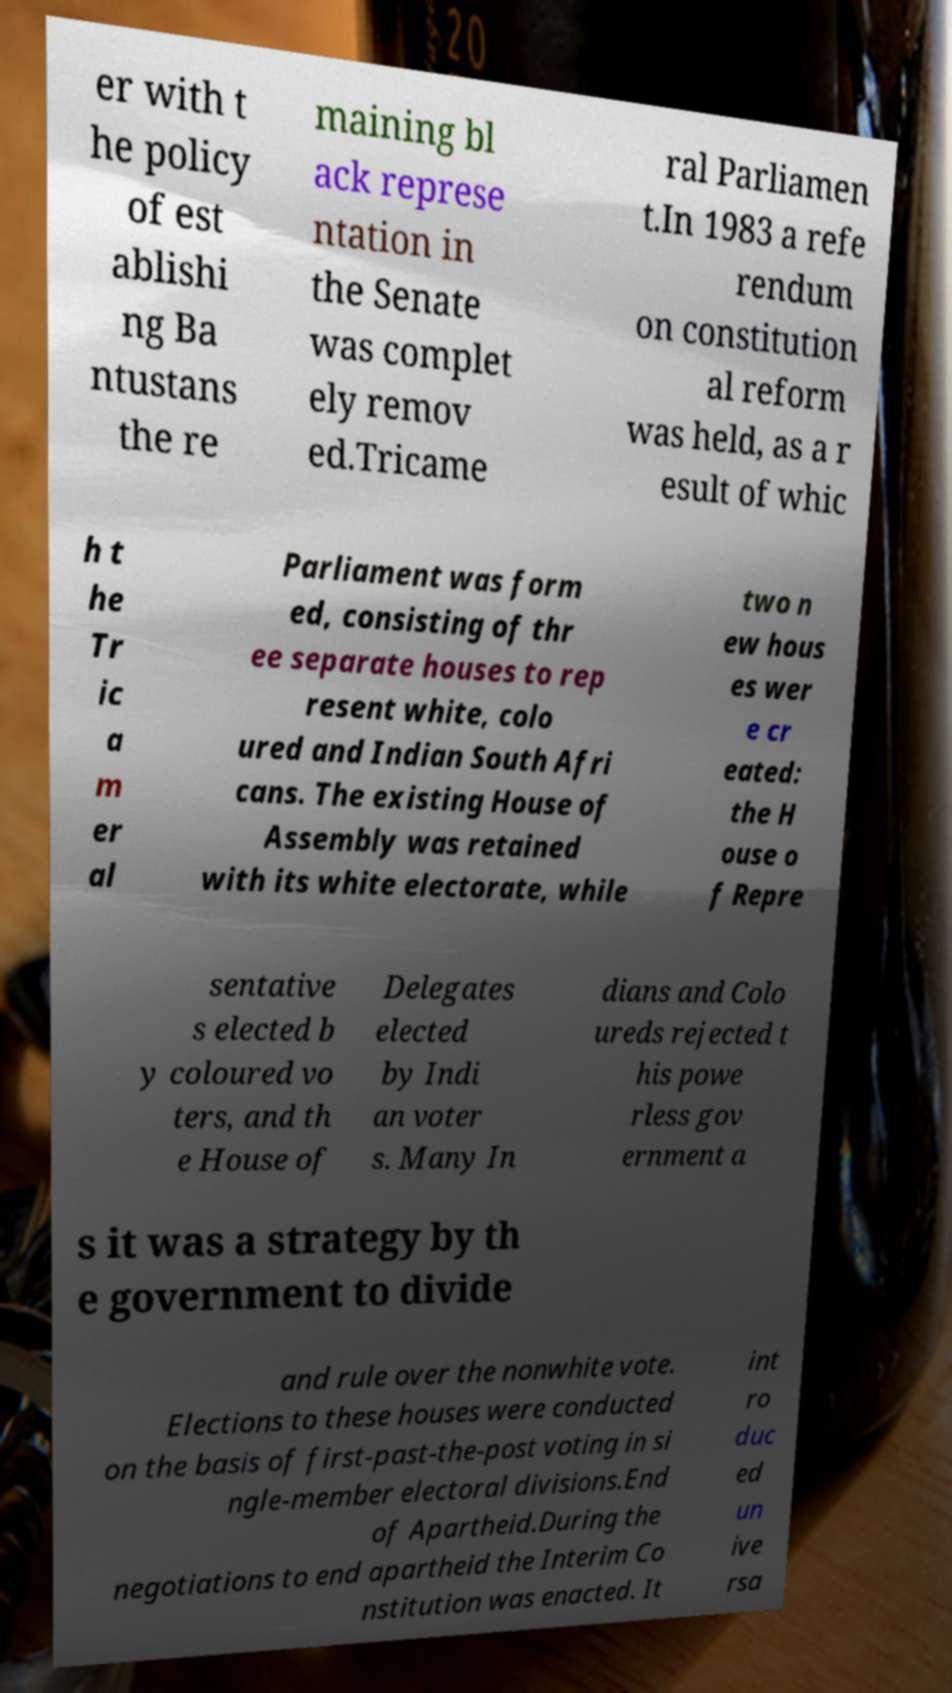For documentation purposes, I need the text within this image transcribed. Could you provide that? er with t he policy of est ablishi ng Ba ntustans the re maining bl ack represe ntation in the Senate was complet ely remov ed.Tricame ral Parliamen t.In 1983 a refe rendum on constitution al reform was held, as a r esult of whic h t he Tr ic a m er al Parliament was form ed, consisting of thr ee separate houses to rep resent white, colo ured and Indian South Afri cans. The existing House of Assembly was retained with its white electorate, while two n ew hous es wer e cr eated: the H ouse o f Repre sentative s elected b y coloured vo ters, and th e House of Delegates elected by Indi an voter s. Many In dians and Colo ureds rejected t his powe rless gov ernment a s it was a strategy by th e government to divide and rule over the nonwhite vote. Elections to these houses were conducted on the basis of first-past-the-post voting in si ngle-member electoral divisions.End of Apartheid.During the negotiations to end apartheid the Interim Co nstitution was enacted. It int ro duc ed un ive rsa 